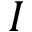<formula> <loc_0><loc_0><loc_500><loc_500>I</formula> 